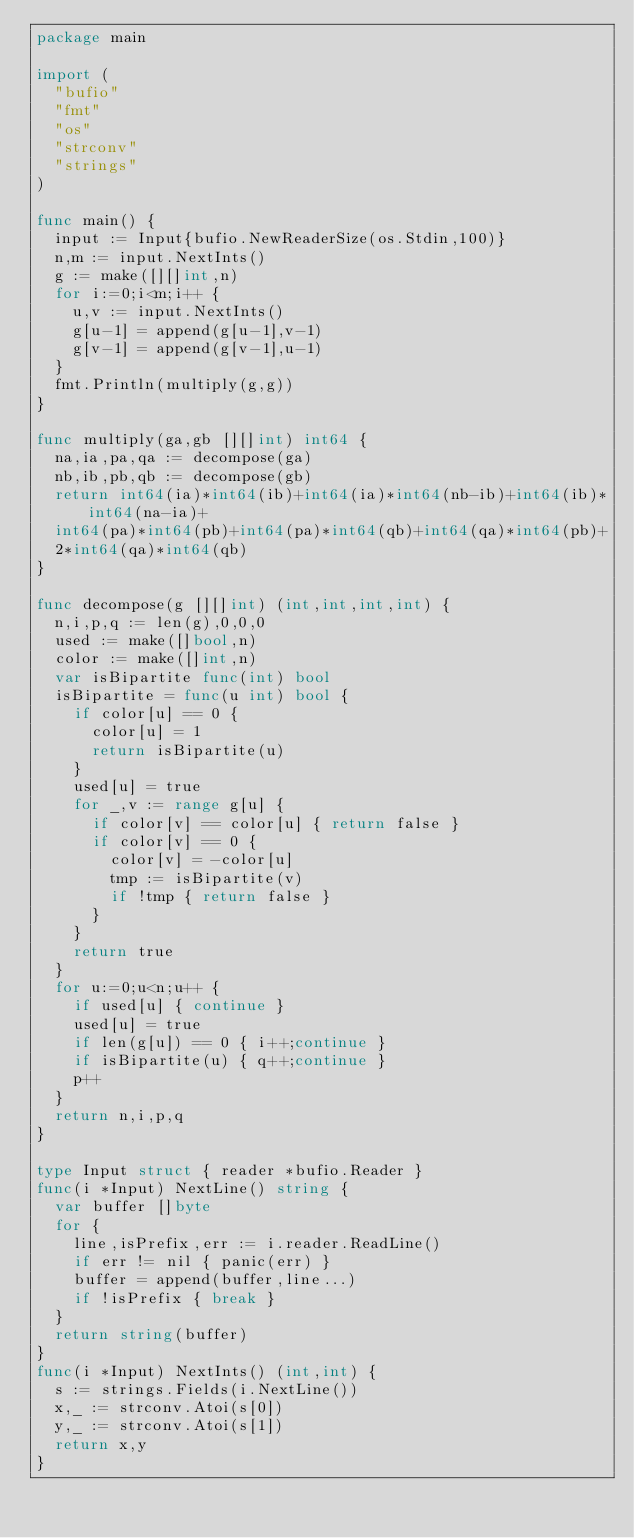Convert code to text. <code><loc_0><loc_0><loc_500><loc_500><_Go_>package main

import (
  "bufio"
  "fmt"
  "os"
  "strconv"
  "strings"
)

func main() {
  input := Input{bufio.NewReaderSize(os.Stdin,100)}
  n,m := input.NextInts()
  g := make([][]int,n)
  for i:=0;i<m;i++ {
    u,v := input.NextInts()
    g[u-1] = append(g[u-1],v-1)
    g[v-1] = append(g[v-1],u-1)
  }
  fmt.Println(multiply(g,g))
}

func multiply(ga,gb [][]int) int64 {
  na,ia,pa,qa := decompose(ga)
  nb,ib,pb,qb := decompose(gb)
  return int64(ia)*int64(ib)+int64(ia)*int64(nb-ib)+int64(ib)*int64(na-ia)+
  int64(pa)*int64(pb)+int64(pa)*int64(qb)+int64(qa)*int64(pb)+
  2*int64(qa)*int64(qb)
}

func decompose(g [][]int) (int,int,int,int) {
  n,i,p,q := len(g),0,0,0
  used := make([]bool,n)
  color := make([]int,n)
  var isBipartite func(int) bool
  isBipartite = func(u int) bool {
    if color[u] == 0 {
      color[u] = 1
      return isBipartite(u)
    }
    used[u] = true
    for _,v := range g[u] {
      if color[v] == color[u] { return false }
      if color[v] == 0 {
        color[v] = -color[u]
        tmp := isBipartite(v)
        if !tmp { return false }
      }
    }
    return true
  }
  for u:=0;u<n;u++ {
    if used[u] { continue }
    used[u] = true
    if len(g[u]) == 0 { i++;continue }
    if isBipartite(u) { q++;continue }
    p++
  }
  return n,i,p,q
}

type Input struct { reader *bufio.Reader }
func(i *Input) NextLine() string {
  var buffer []byte
  for {
    line,isPrefix,err := i.reader.ReadLine()
    if err != nil { panic(err) }
    buffer = append(buffer,line...)
    if !isPrefix { break }
  }
  return string(buffer)
}
func(i *Input) NextInts() (int,int) {
  s := strings.Fields(i.NextLine())
  x,_ := strconv.Atoi(s[0])
  y,_ := strconv.Atoi(s[1])
  return x,y
}</code> 